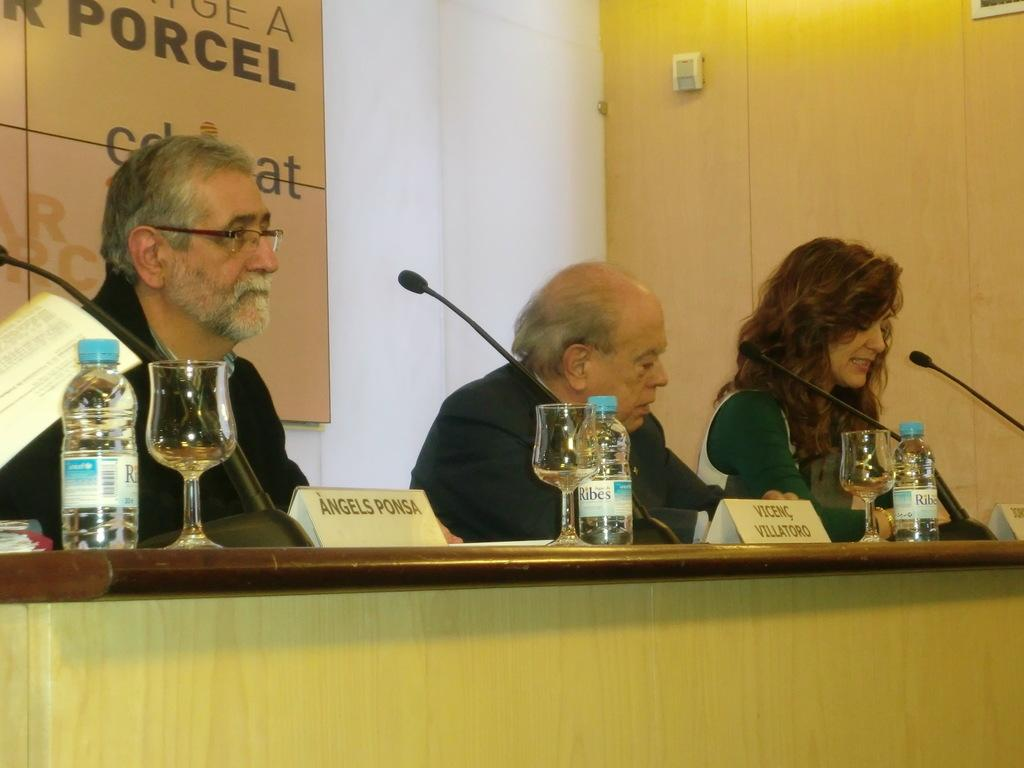<image>
Present a compact description of the photo's key features. andels ponsa and vicene villatoro at a confrence table 